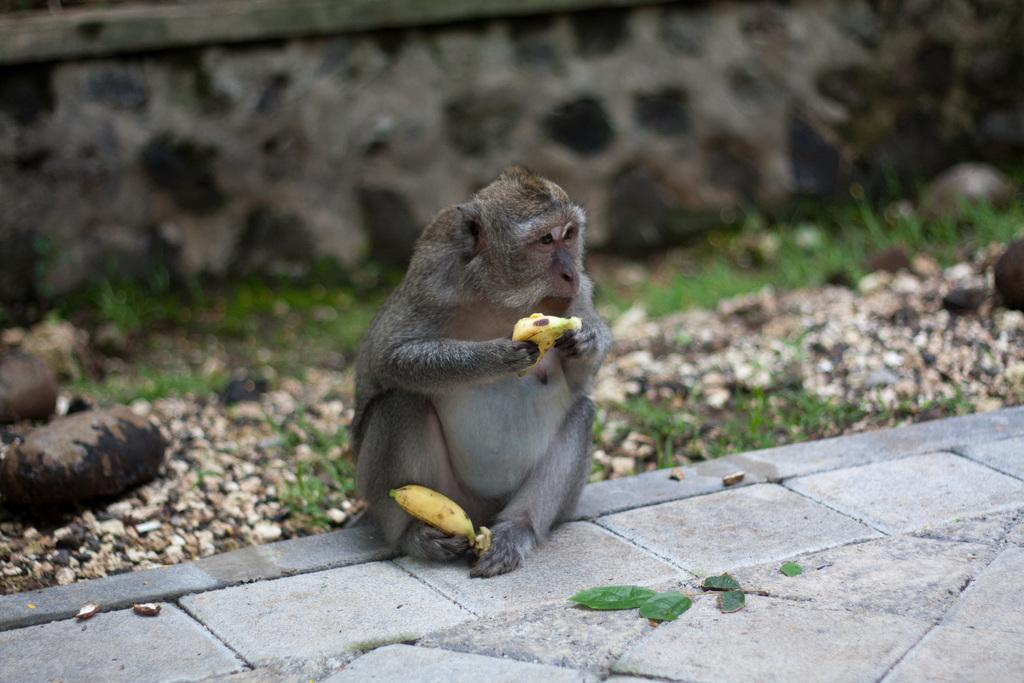What can be seen in the image that people walk on? There is a path in the image that people can walk on. What animal is present on the path? A monkey is present on the path. What is the monkey holding in the image? The monkey is holding two bananas. What type of natural environment is visible in the background of the image? There is grass in the background of the image. What architectural feature can be seen in the background of the image? There is a wall in the background of the image. What type of crate is the monkey sitting on in the image? There is no crate present in the image; the monkey is standing on the path. What type of yam is the monkey eating in the image? There is no yam present in the image; the monkey is holding two bananas. 